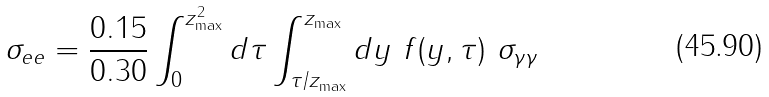Convert formula to latex. <formula><loc_0><loc_0><loc_500><loc_500>\sigma _ { e e } = \frac { 0 . 1 5 } { 0 . 3 0 } \int _ { 0 } ^ { z _ { \max } ^ { 2 } } d \tau \int _ { \tau / z _ { \max } } ^ { z _ { \max } } d y \ f ( y , \tau ) \ \sigma _ { \gamma \gamma }</formula> 